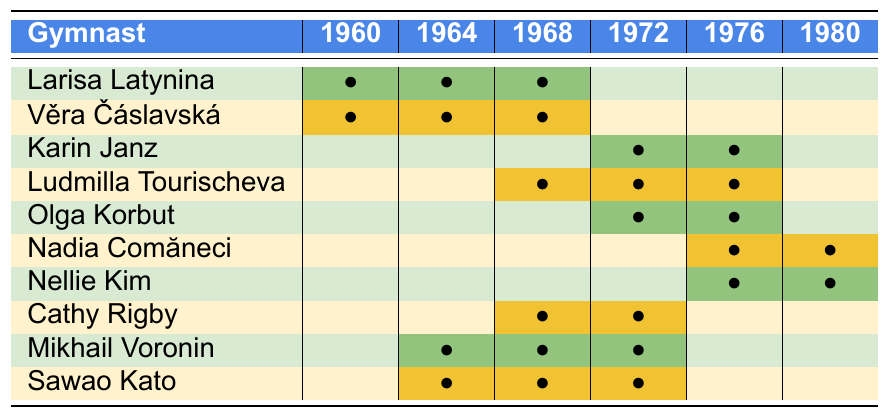What is the total number of gymnasts who competed in the 1976 Olympics? From the table, the gymnasts that competed in 1976 are Larisa Latynina, Ludmilla Tourischeva, Olga Korbut, Nadia Comăneci, Nellie Kim, and Cathy Rigby. Counting these entries gives us a total of 6 gymnasts.
Answer: 6 Which gymnast competed in the most Olympic Games? By reviewing the 'gamesCompeted' column for each gymnast, Larisa Latynina, Věra Čáslavská, Ludmilla Tourischeva, Mikhail Voronin, and Sawao Kato all competed in 3 Olympic Games, which is the highest number.
Answer: Larisa Latynina, Věra Čáslavská, Ludmilla Tourischeva, Mikhail Voronin, and Sawao Kato How many gymnasts from the Soviet Union competed in more than 2 Olympic Games? Examining the entries under the Soviet Union, Larisa Latynina, Ludmilla Tourischeva, and Mikhail Voronin all competed in 3 Olympic Games. Thus, there are 3 gymnasts from the Soviet Union with more than 2 competitions.
Answer: 3 What is the average number of Olympic Games competed in by each gymnast listed? To find the average, we first sum the total games: (3+3+2+3+2+2+2+2+3+3) = 24. There are 10 gymnasts, so the average is 24/10 = 2.4.
Answer: 2.4 Did any gymnast from East Germany compete in the 1960 Olympics? Karin Janz is the only gymnast listed from East Germany, and she did not compete in the 1960 Olympics according to the table.
Answer: No Which country had the highest representation in terms of multiple Olympic competitions? The Soviet Union has 5 gymnasts listed (Larisa Latynina, Ludmilla Tourischeva, Olga Korbut, Mikhail Voronin, and Nellie Kim) competing in multiple Olympic Games. No other country matches this number.
Answer: Soviet Union How many gymnasts competed in exactly 2 Olympic Games? From the table, we identify 4 gymnasts (Karin Janz, Olga Korbut, Nadia Comăneci, and Cathy Rigby) who competed in exactly 2 Olympic Games.
Answer: 4 If we consider only gymnasts who competed in the 1972 Olympics, which gymnast had the highest total Olympic appearances? Ludmilla Tourischeva competed in 3 Olympics and participated in the 1972 Games. No other gymnast competing that year has more than 2 total appearances.
Answer: Ludmilla Tourischeva Which gymnast represented Czechoslovakia, and how many games did she compete in? The gymnast from Czechoslovakia is Věra Čáslavská, and she competed in 3 Olympic Games.
Answer: Věra Čáslavská, 3 Was there any gymnast that competed only in the 1976 and 1980 Olympic Games? By reviewing the table, there is no gymnast who is exclusively represented in just the 1976 and 1980 Olympic Games.
Answer: No 